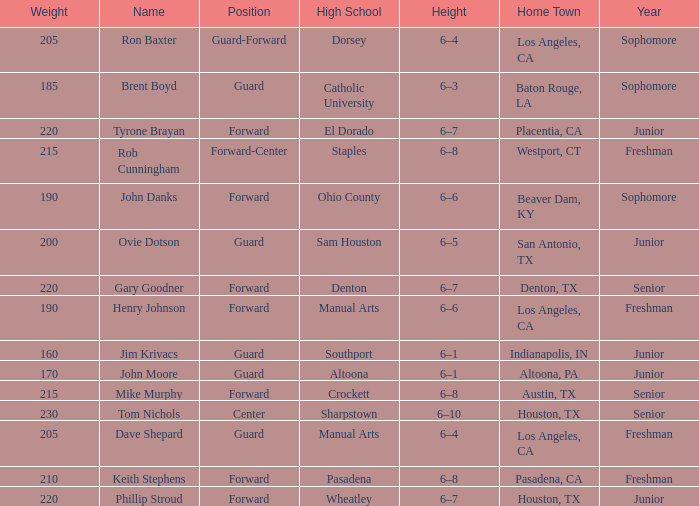What is the name with a year as a freshman, a home town of los angeles, ca, and a height measuring 6-4? Dave Shepard. 